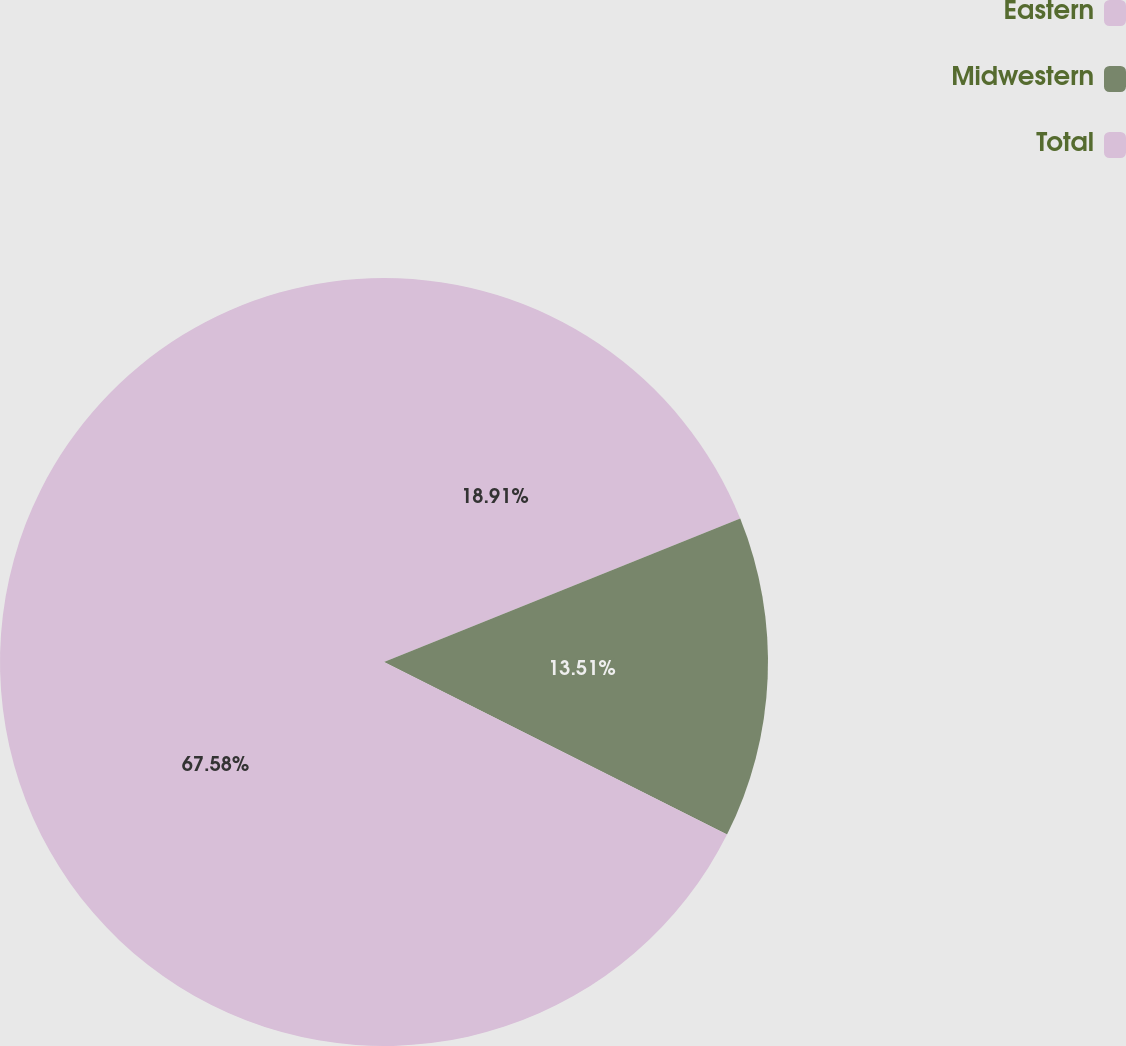Convert chart. <chart><loc_0><loc_0><loc_500><loc_500><pie_chart><fcel>Eastern<fcel>Midwestern<fcel>Total<nl><fcel>18.91%<fcel>13.51%<fcel>67.58%<nl></chart> 